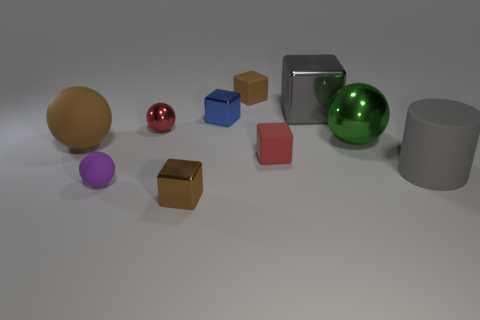Subtract 2 spheres. How many spheres are left? 2 Subtract all gray blocks. How many blocks are left? 4 Subtract all large metal blocks. How many blocks are left? 4 Subtract all gray spheres. Subtract all yellow blocks. How many spheres are left? 4 Subtract all balls. How many objects are left? 6 Add 2 brown metal blocks. How many brown metal blocks are left? 3 Add 3 cylinders. How many cylinders exist? 4 Subtract 2 brown cubes. How many objects are left? 8 Subtract all small blue metal things. Subtract all big cyan matte objects. How many objects are left? 9 